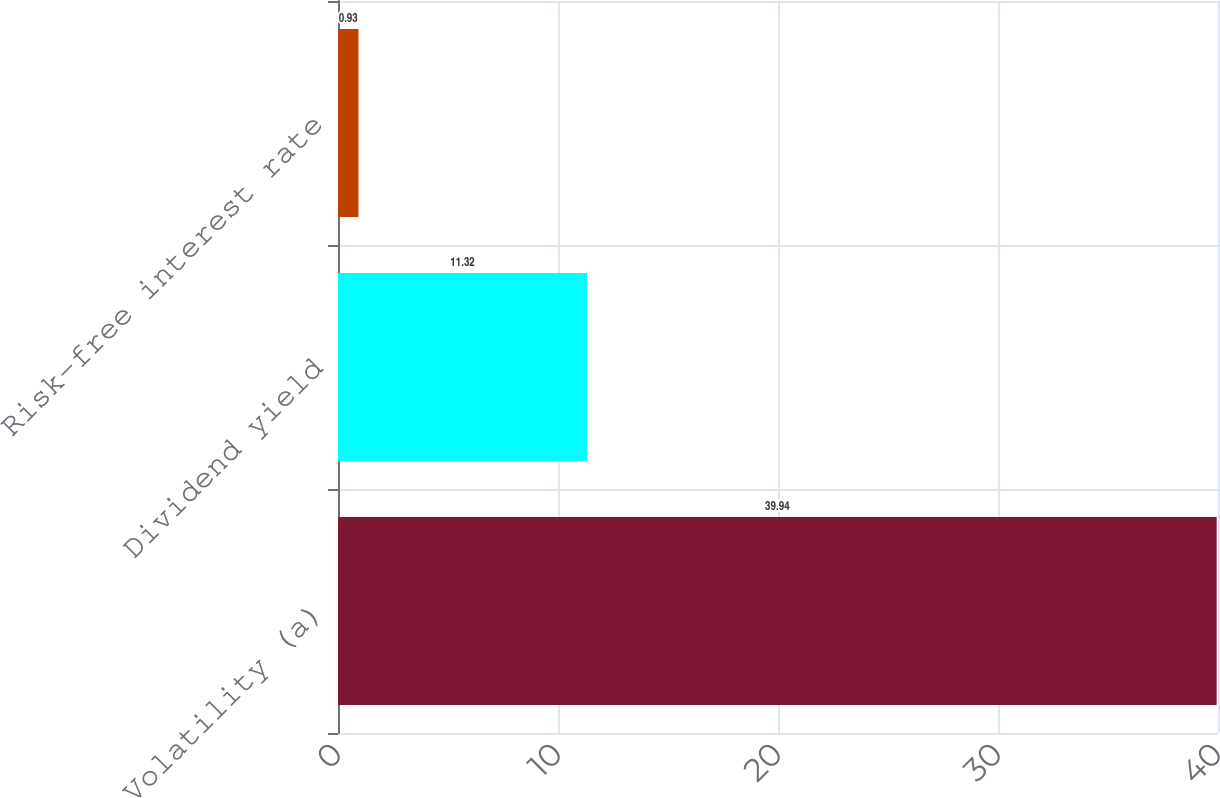Convert chart. <chart><loc_0><loc_0><loc_500><loc_500><bar_chart><fcel>Volatility (a)<fcel>Dividend yield<fcel>Risk-free interest rate<nl><fcel>39.94<fcel>11.32<fcel>0.93<nl></chart> 